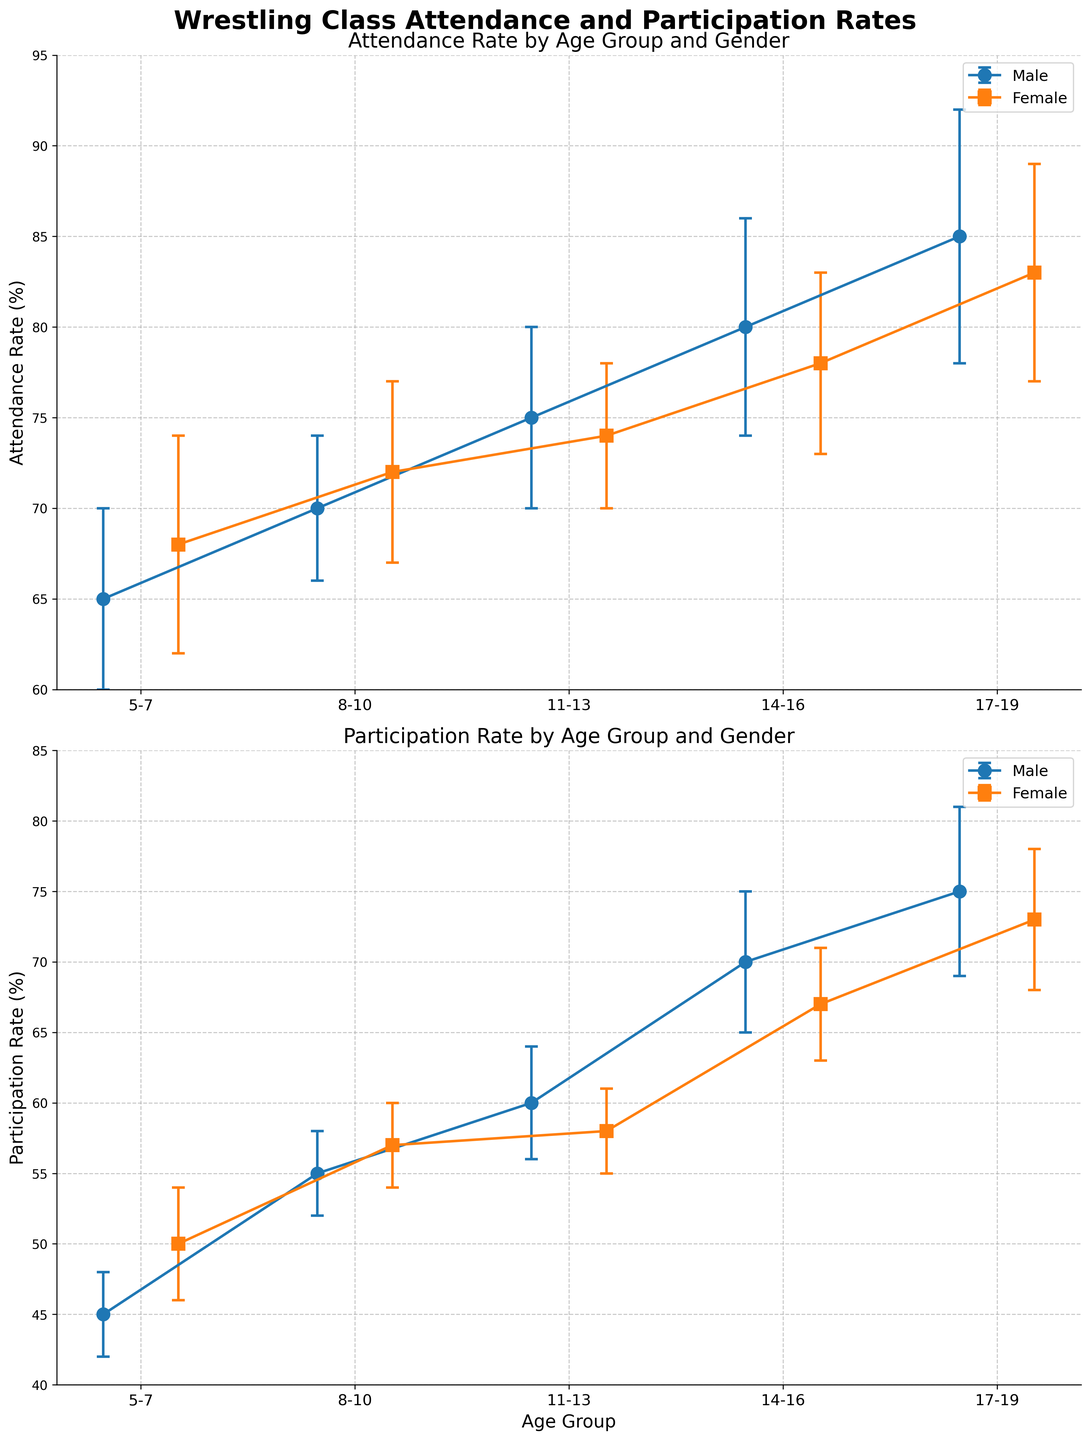what is the title of the figure? The title is displayed at the top of the figure in a larger font size. It encapsulates the central theme of the plot.
Answer: Wrestling Class Attendance and Participation Rates What is the attendance rate for 8-10 year old boys? Look at the 'Attendance Rate by Age Group and Gender' subplot, locate the '8-10' age group on the x-axis, and find the value for 'Male' (blue color).
Answer: 70% Which gender has a higher participation rate in the 14-16 age group? In the 'Participation Rate by Age Group and Gender' subplot, compare the participation rates for 'Male' and 'Female' within the '14-16' age group.
Answer: Male How does the attendance rate of 11-13 year old girls compare to that of 17-19 year old boys? Locate both age groups on the 'Attendance Rate by Age Group and Gender' subplot and compare the values shown for 'Female' in the '11-13' group and 'Male' in the '17-19' group.
Answer: 75% (Male 17-19) is higher than 74% (Female 11-13) What is the difference in the participation rates of 5-7 year old girls and 17-19 year old girls? Look at the 'Participation Rate by Age Group and Gender' subplot, find the rates for 'Female' in the '5-7' and '17-19' age groups, and subtract the former from the latter.
Answer: 73% - 50% = 23% What age group has the highest attendance rate for both genders combined? Check both subplots for the highest bar heights for each gender and compare across age groups to find the one with the maximum attendance rate.
Answer: 17-19 What is the average participation rate of the 14-16 age group for both genders? Add the participation rates for 'Male' and 'Female' in the '14-16' age group and divide by 2.
Answer: (70% + 67%) / 2 = 68.5% Which age group and gender have the largest error bars in attendance rate? Examine the length of the error bars in the 'Attendance Rate by Age Group and Gender' subplot for each gender and age group to identify the longest one.
Answer: 17-19 Male What is the attendance rate for 5-7 year old boys and what is its error margin? Identify the 'Attendance Rate by Age Group and Gender' subplot, locate the '5-7' age group for 'Male', and find both the rate and the error bar length.
Answer: 65% with an error margin of ±5% 